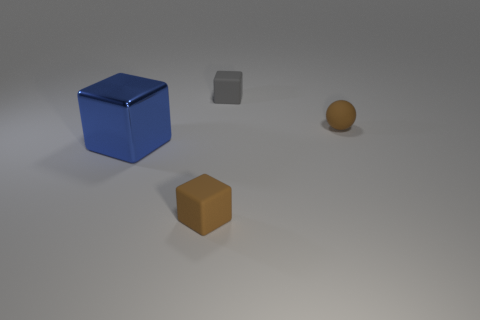What is the shape of the small thing that is the same color as the tiny ball?
Your response must be concise. Cube. There is a gray rubber thing; does it have the same shape as the small matte object that is in front of the tiny brown ball?
Ensure brevity in your answer.  Yes. What color is the object that is both to the right of the blue metal block and to the left of the tiny gray object?
Your answer should be very brief. Brown. What is the cube that is to the right of the brown thing that is on the left side of the brown rubber object that is behind the brown block made of?
Keep it short and to the point. Rubber. What is the material of the big object?
Your response must be concise. Metal. What size is the brown matte thing that is the same shape as the blue object?
Offer a very short reply. Small. Is the matte sphere the same color as the large thing?
Ensure brevity in your answer.  No. What number of other objects are the same material as the tiny brown block?
Your response must be concise. 2. Is the number of blocks that are behind the tiny gray thing the same as the number of brown matte blocks?
Give a very brief answer. No. Do the rubber cube that is in front of the shiny cube and the blue cube have the same size?
Your answer should be very brief. No. 